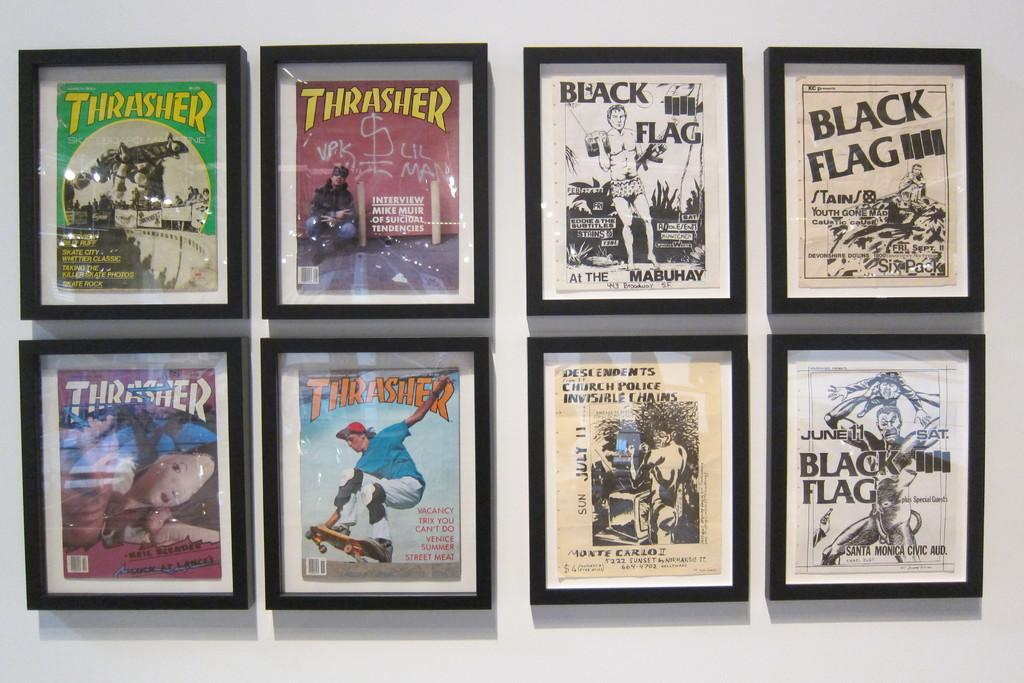<image>
Relay a brief, clear account of the picture shown. Some framed copies of THRASHER magazine are hung on the wall. 